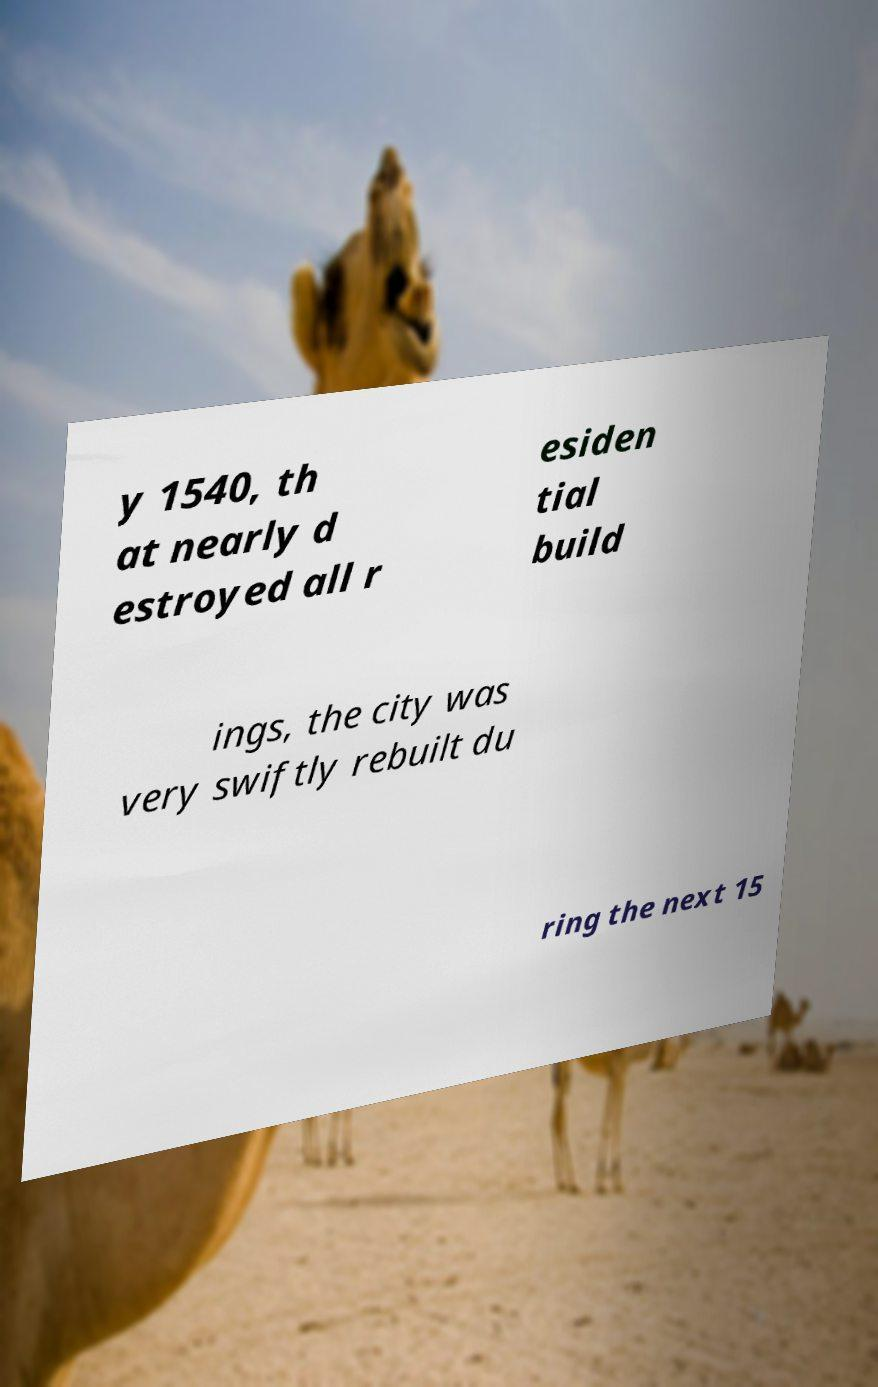Could you assist in decoding the text presented in this image and type it out clearly? y 1540, th at nearly d estroyed all r esiden tial build ings, the city was very swiftly rebuilt du ring the next 15 